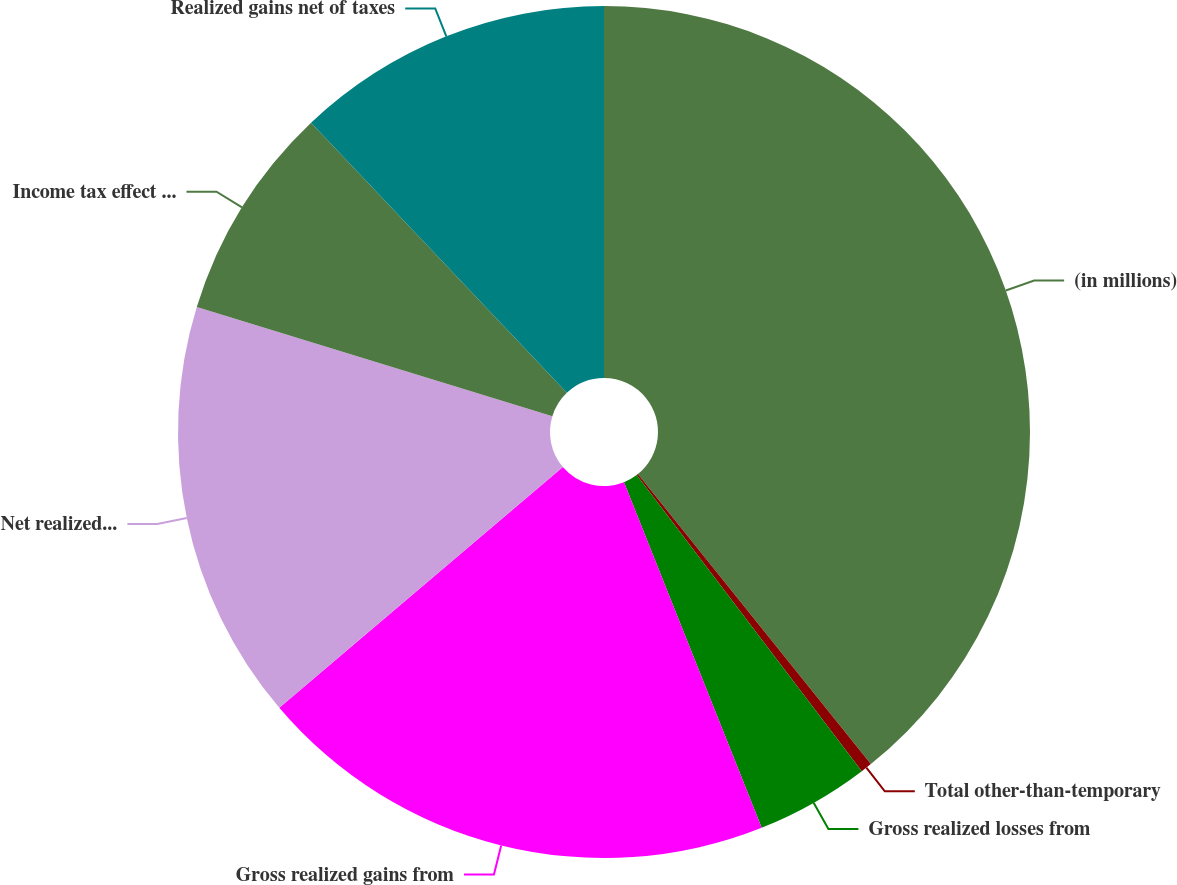Convert chart to OTSL. <chart><loc_0><loc_0><loc_500><loc_500><pie_chart><fcel>(in millions)<fcel>Total other-than-temporary<fcel>Gross realized losses from<fcel>Gross realized gains from<fcel>Net realized gains (included<fcel>Income tax effect (included in<fcel>Realized gains net of taxes<nl><fcel>39.23%<fcel>0.43%<fcel>4.31%<fcel>19.83%<fcel>15.95%<fcel>8.19%<fcel>12.07%<nl></chart> 